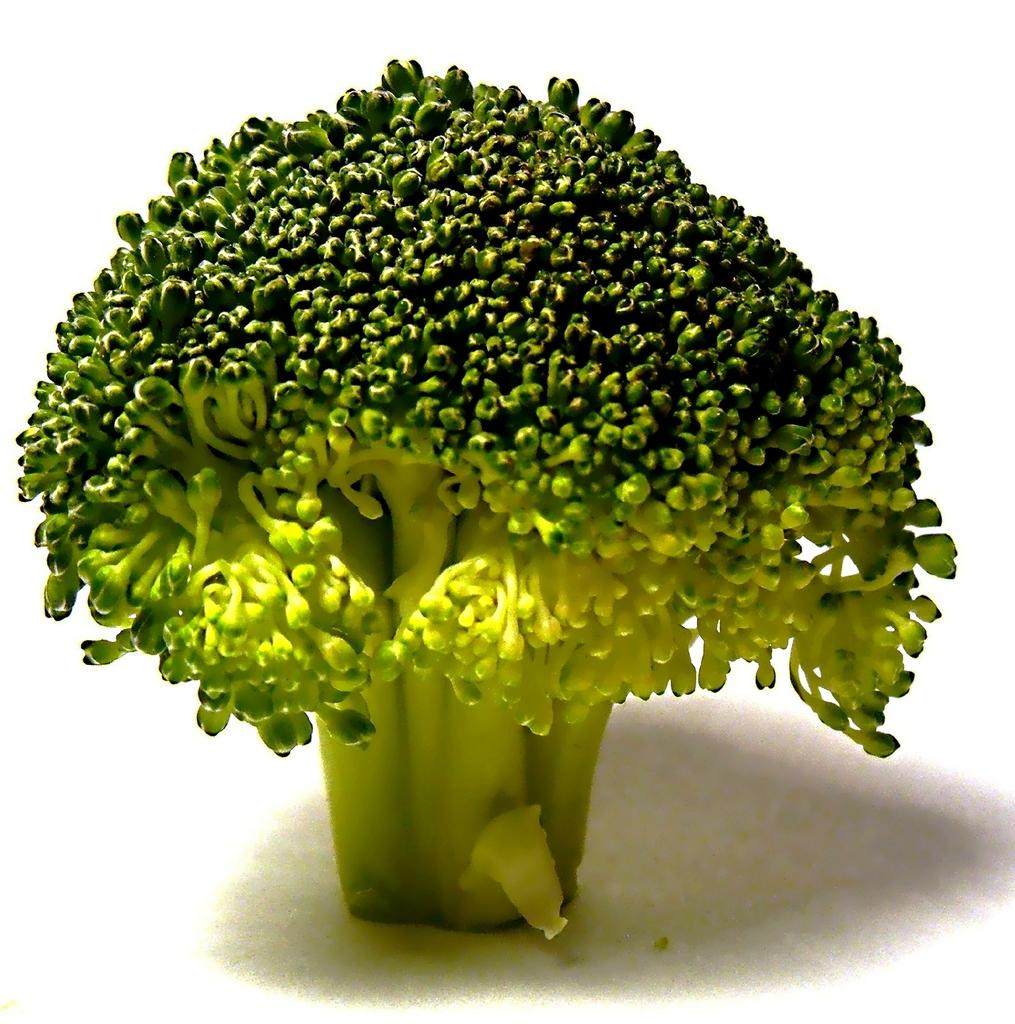What type of food can be seen in the image? There is a green vegetable in the image. What color is the background of the image? The background of the image is white. How many babies are playing with the horn in the image? There are no babies or horns present in the image; it only features a green vegetable and a white background. 